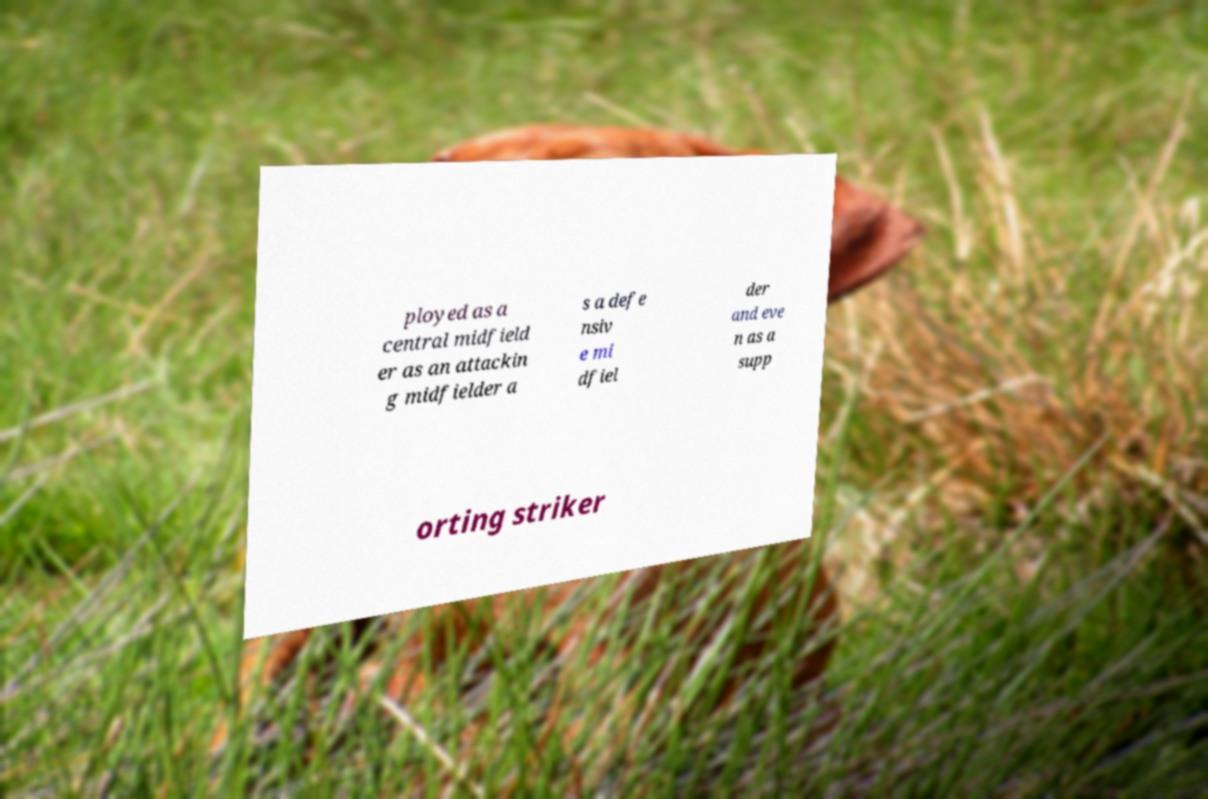Can you read and provide the text displayed in the image?This photo seems to have some interesting text. Can you extract and type it out for me? ployed as a central midfield er as an attackin g midfielder a s a defe nsiv e mi dfiel der and eve n as a supp orting striker 